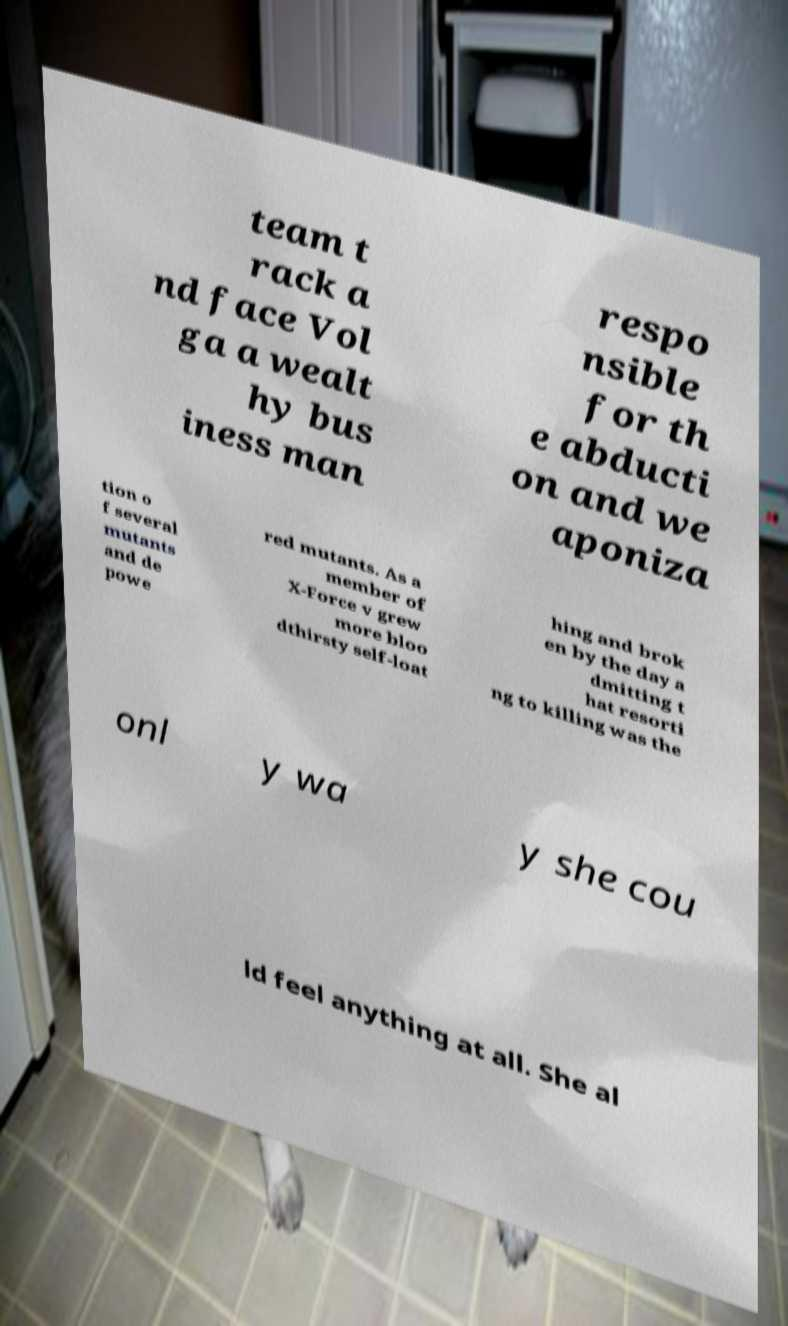Can you read and provide the text displayed in the image?This photo seems to have some interesting text. Can you extract and type it out for me? team t rack a nd face Vol ga a wealt hy bus iness man respo nsible for th e abducti on and we aponiza tion o f several mutants and de powe red mutants. As a member of X-Force v grew more bloo dthirsty self-loat hing and brok en by the day a dmitting t hat resorti ng to killing was the onl y wa y she cou ld feel anything at all. She al 